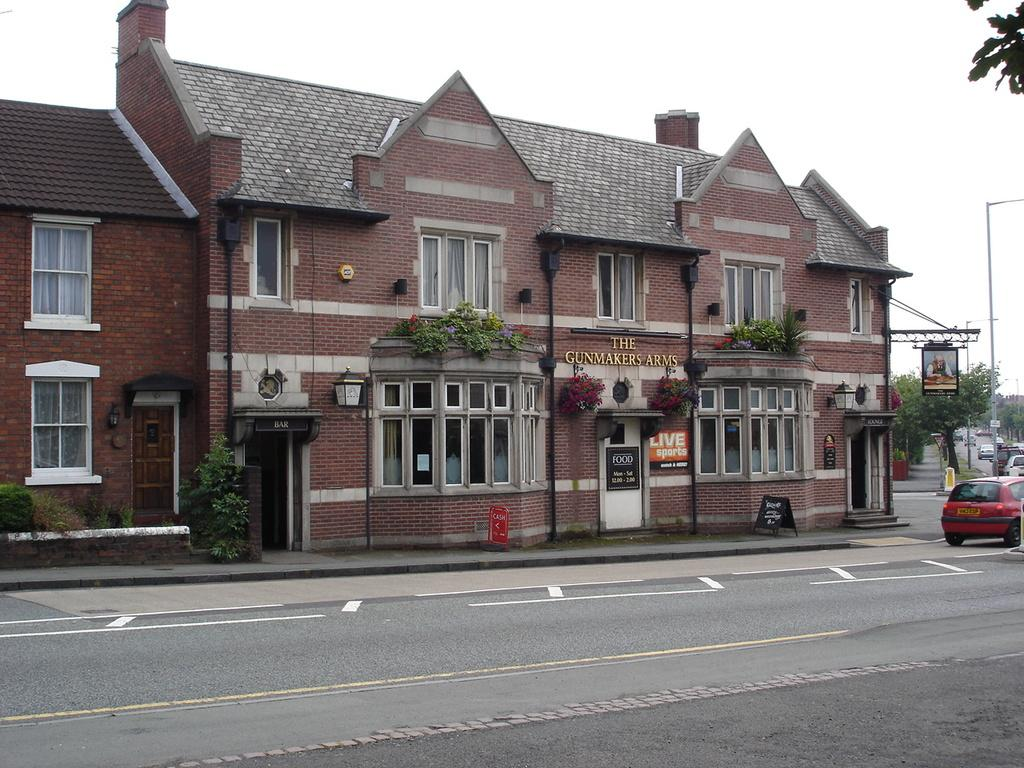What type of structures can be seen in the image? There are buildings with windows in the image. What decorative or informative items are present in the image? Banners are present in the image. What type of vegetation is visible in the image? Trees are visible in the image. What type of vertical structures are present in the image? Poles are present in the image. What type of transportation is visible in the image? Vehicles are on the road in the image. What is visible in the background of the image? The sky is visible in the background of the image. What type of list can be seen hanging from the neck of the person in the image? There is no person or list present in the image. How is the waste being managed in the image? There is no mention of waste management in the image. 